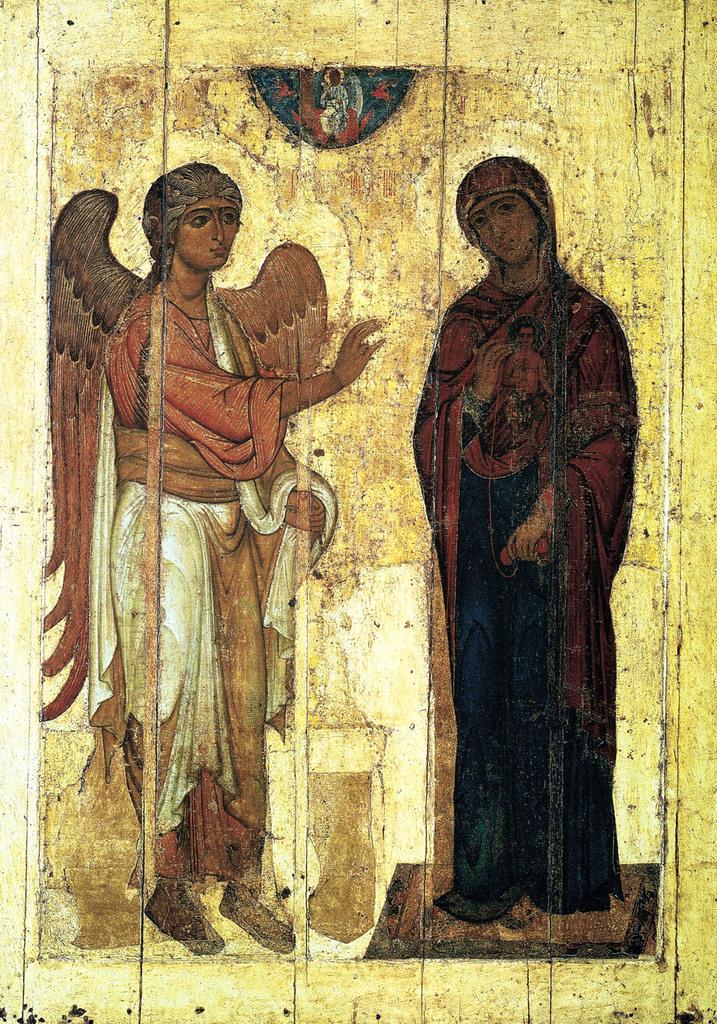Please provide a concise description of this image. In this picture we can observe two paintings on the yellow color wooden wall. On the left side there is a person with wings. On the right side there is a woman standing, wearing dark color dress. In the background there is a wooden wall. 